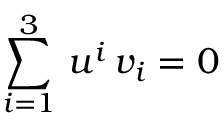<formula> <loc_0><loc_0><loc_500><loc_500>\sum _ { i = 1 } ^ { 3 } \, u ^ { i } \, v _ { i } = 0</formula> 